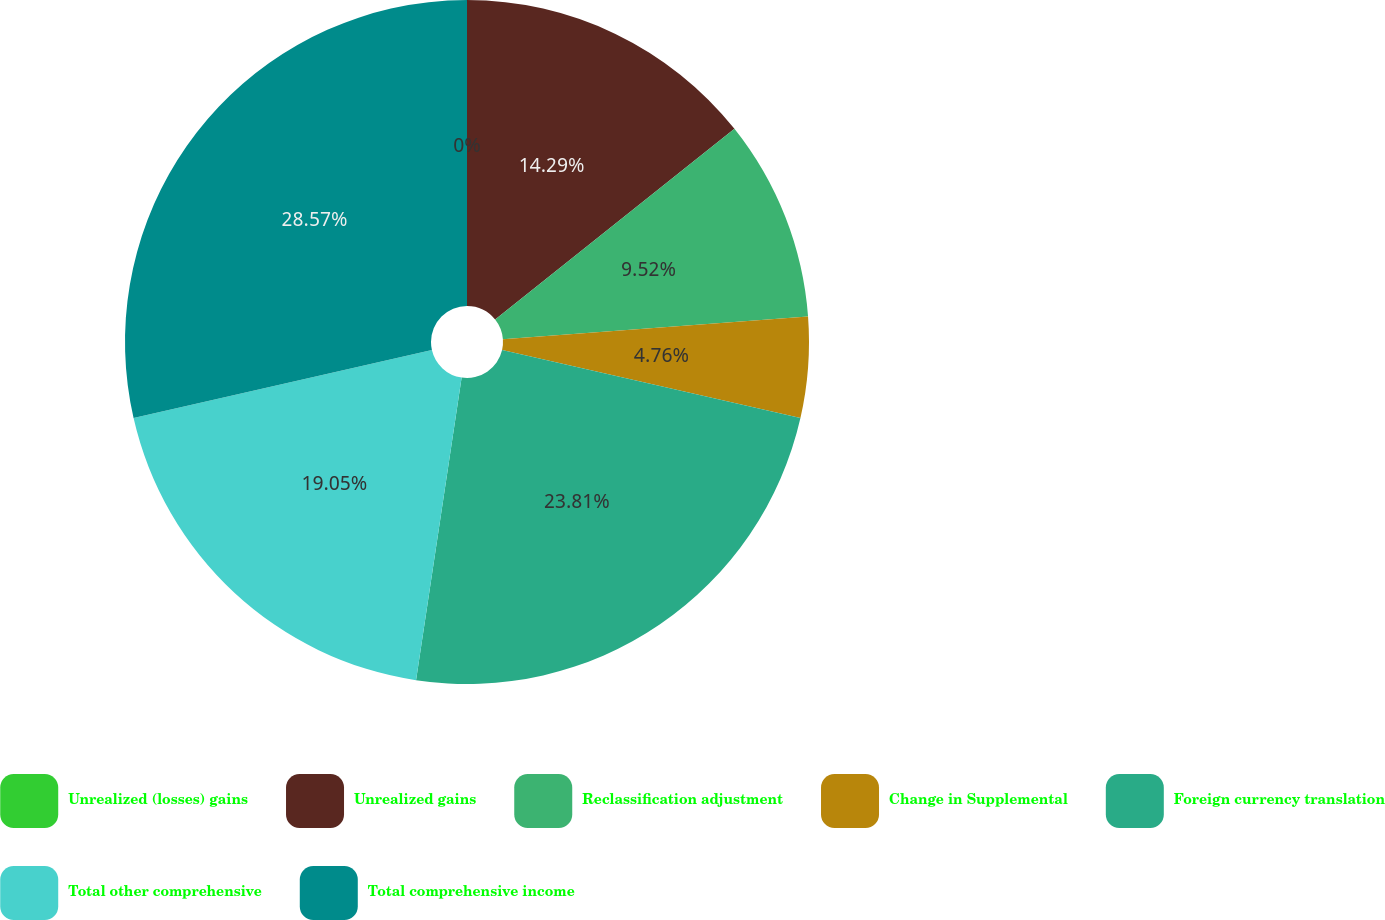<chart> <loc_0><loc_0><loc_500><loc_500><pie_chart><fcel>Unrealized (losses) gains<fcel>Unrealized gains<fcel>Reclassification adjustment<fcel>Change in Supplemental<fcel>Foreign currency translation<fcel>Total other comprehensive<fcel>Total comprehensive income<nl><fcel>0.0%<fcel>14.29%<fcel>9.52%<fcel>4.76%<fcel>23.81%<fcel>19.05%<fcel>28.57%<nl></chart> 